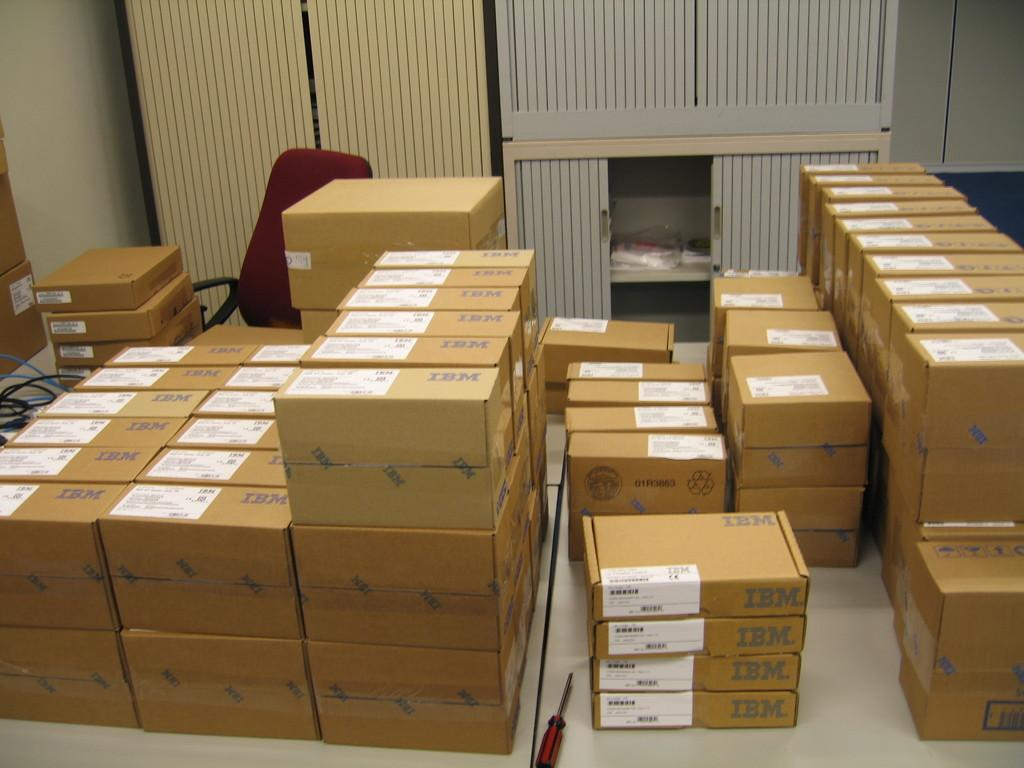Provide a one-sentence caption for the provided image. a bunch of boxes with the word IBM printed. 